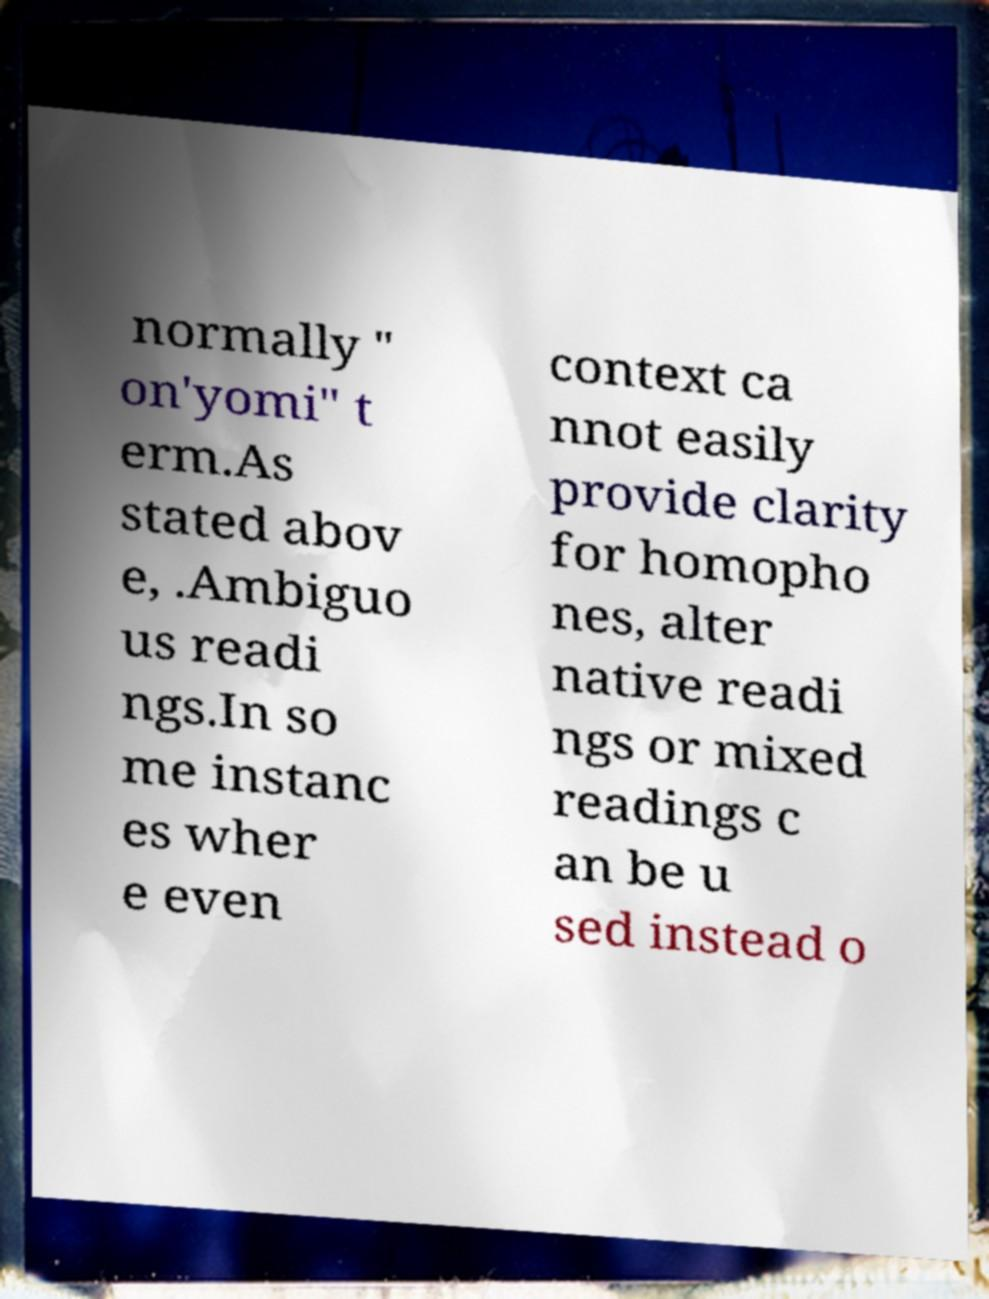For documentation purposes, I need the text within this image transcribed. Could you provide that? normally " on'yomi" t erm.As stated abov e, .Ambiguo us readi ngs.In so me instanc es wher e even context ca nnot easily provide clarity for homopho nes, alter native readi ngs or mixed readings c an be u sed instead o 